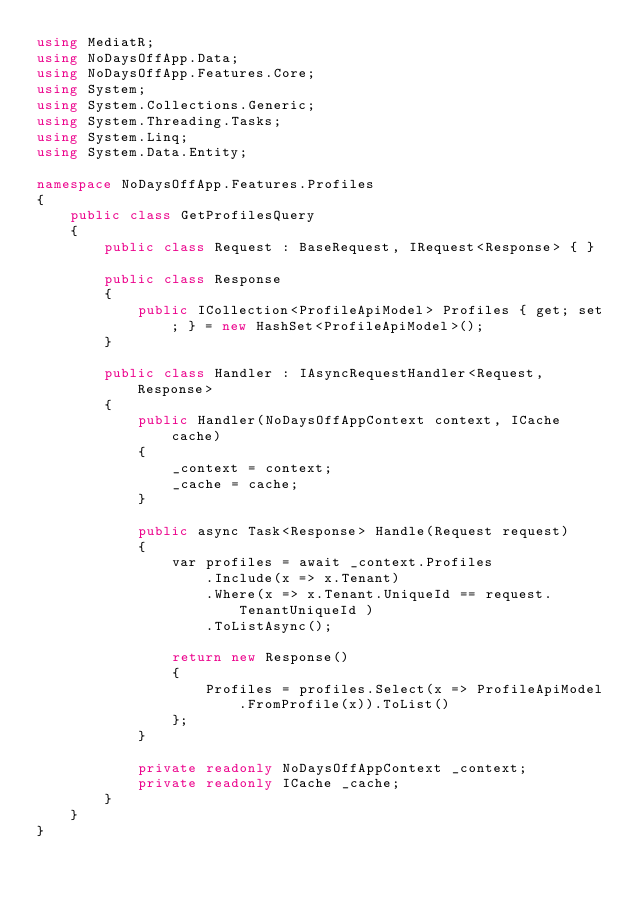<code> <loc_0><loc_0><loc_500><loc_500><_C#_>using MediatR;
using NoDaysOffApp.Data;
using NoDaysOffApp.Features.Core;
using System;
using System.Collections.Generic;
using System.Threading.Tasks;
using System.Linq;
using System.Data.Entity;

namespace NoDaysOffApp.Features.Profiles
{
    public class GetProfilesQuery
    {
        public class Request : BaseRequest, IRequest<Response> { }

        public class Response
        {
            public ICollection<ProfileApiModel> Profiles { get; set; } = new HashSet<ProfileApiModel>();
        }

        public class Handler : IAsyncRequestHandler<Request, Response>
        {
            public Handler(NoDaysOffAppContext context, ICache cache)
            {
                _context = context;
                _cache = cache;
            }

            public async Task<Response> Handle(Request request)
            {
                var profiles = await _context.Profiles
                    .Include(x => x.Tenant)
                    .Where(x => x.Tenant.UniqueId == request.TenantUniqueId )
                    .ToListAsync();

                return new Response()
                {
                    Profiles = profiles.Select(x => ProfileApiModel.FromProfile(x)).ToList()
                };
            }

            private readonly NoDaysOffAppContext _context;
            private readonly ICache _cache;
        }
    }
}
</code> 